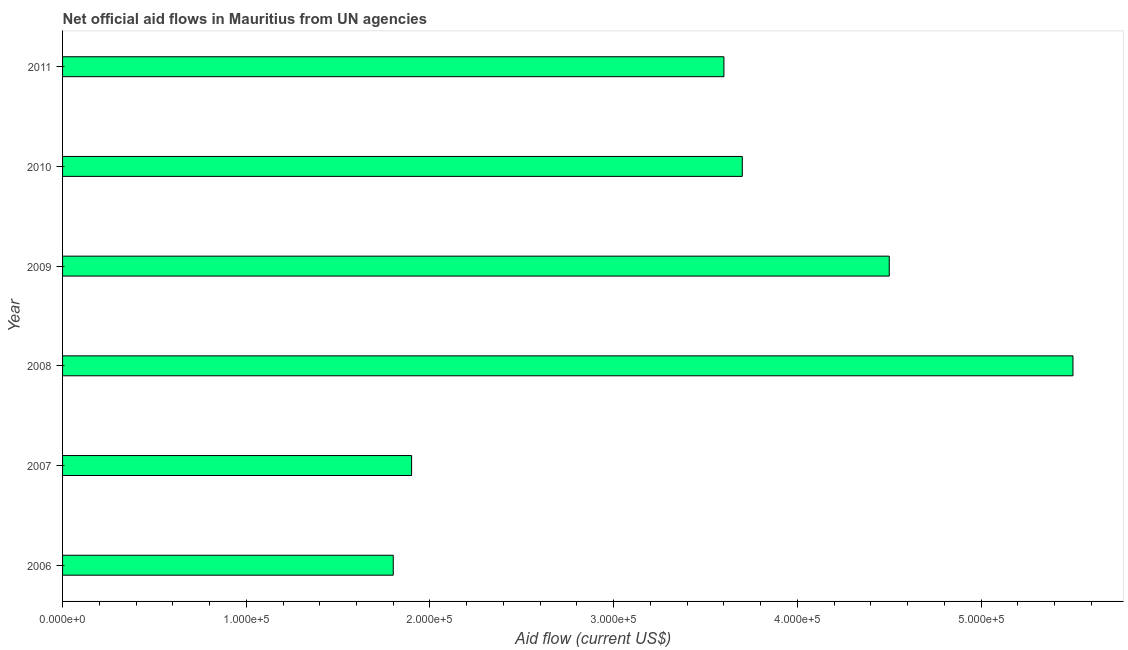What is the title of the graph?
Keep it short and to the point. Net official aid flows in Mauritius from UN agencies. What is the label or title of the X-axis?
Keep it short and to the point. Aid flow (current US$). What is the label or title of the Y-axis?
Your answer should be compact. Year. Across all years, what is the minimum net official flows from un agencies?
Your answer should be very brief. 1.80e+05. In which year was the net official flows from un agencies maximum?
Make the answer very short. 2008. What is the sum of the net official flows from un agencies?
Make the answer very short. 2.10e+06. What is the median net official flows from un agencies?
Make the answer very short. 3.65e+05. In how many years, is the net official flows from un agencies greater than 340000 US$?
Give a very brief answer. 4. Do a majority of the years between 2009 and 2011 (inclusive) have net official flows from un agencies greater than 420000 US$?
Your response must be concise. No. What is the ratio of the net official flows from un agencies in 2006 to that in 2009?
Offer a terse response. 0.4. Is the net official flows from un agencies in 2008 less than that in 2009?
Provide a short and direct response. No. Is the difference between the net official flows from un agencies in 2006 and 2011 greater than the difference between any two years?
Your answer should be very brief. No. What is the difference between the highest and the second highest net official flows from un agencies?
Offer a very short reply. 1.00e+05. What is the difference between the highest and the lowest net official flows from un agencies?
Offer a terse response. 3.70e+05. How many bars are there?
Your answer should be very brief. 6. Are all the bars in the graph horizontal?
Your answer should be compact. Yes. How many years are there in the graph?
Your response must be concise. 6. What is the difference between two consecutive major ticks on the X-axis?
Give a very brief answer. 1.00e+05. Are the values on the major ticks of X-axis written in scientific E-notation?
Your answer should be very brief. Yes. What is the Aid flow (current US$) of 2006?
Make the answer very short. 1.80e+05. What is the Aid flow (current US$) in 2007?
Ensure brevity in your answer.  1.90e+05. What is the Aid flow (current US$) of 2011?
Make the answer very short. 3.60e+05. What is the difference between the Aid flow (current US$) in 2006 and 2007?
Keep it short and to the point. -10000. What is the difference between the Aid flow (current US$) in 2006 and 2008?
Offer a terse response. -3.70e+05. What is the difference between the Aid flow (current US$) in 2006 and 2009?
Ensure brevity in your answer.  -2.70e+05. What is the difference between the Aid flow (current US$) in 2006 and 2010?
Your response must be concise. -1.90e+05. What is the difference between the Aid flow (current US$) in 2007 and 2008?
Your answer should be compact. -3.60e+05. What is the difference between the Aid flow (current US$) in 2007 and 2010?
Your answer should be very brief. -1.80e+05. What is the difference between the Aid flow (current US$) in 2009 and 2011?
Provide a short and direct response. 9.00e+04. What is the ratio of the Aid flow (current US$) in 2006 to that in 2007?
Keep it short and to the point. 0.95. What is the ratio of the Aid flow (current US$) in 2006 to that in 2008?
Make the answer very short. 0.33. What is the ratio of the Aid flow (current US$) in 2006 to that in 2009?
Your response must be concise. 0.4. What is the ratio of the Aid flow (current US$) in 2006 to that in 2010?
Offer a terse response. 0.49. What is the ratio of the Aid flow (current US$) in 2006 to that in 2011?
Ensure brevity in your answer.  0.5. What is the ratio of the Aid flow (current US$) in 2007 to that in 2008?
Make the answer very short. 0.34. What is the ratio of the Aid flow (current US$) in 2007 to that in 2009?
Offer a terse response. 0.42. What is the ratio of the Aid flow (current US$) in 2007 to that in 2010?
Keep it short and to the point. 0.51. What is the ratio of the Aid flow (current US$) in 2007 to that in 2011?
Your answer should be compact. 0.53. What is the ratio of the Aid flow (current US$) in 2008 to that in 2009?
Your answer should be very brief. 1.22. What is the ratio of the Aid flow (current US$) in 2008 to that in 2010?
Your answer should be compact. 1.49. What is the ratio of the Aid flow (current US$) in 2008 to that in 2011?
Give a very brief answer. 1.53. What is the ratio of the Aid flow (current US$) in 2009 to that in 2010?
Your answer should be compact. 1.22. What is the ratio of the Aid flow (current US$) in 2009 to that in 2011?
Keep it short and to the point. 1.25. What is the ratio of the Aid flow (current US$) in 2010 to that in 2011?
Your answer should be very brief. 1.03. 